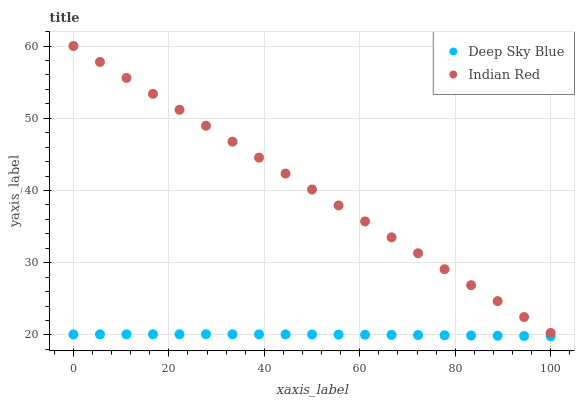Does Deep Sky Blue have the minimum area under the curve?
Answer yes or no. Yes. Does Indian Red have the maximum area under the curve?
Answer yes or no. Yes. Does Deep Sky Blue have the maximum area under the curve?
Answer yes or no. No. Is Indian Red the smoothest?
Answer yes or no. Yes. Is Deep Sky Blue the roughest?
Answer yes or no. Yes. Is Deep Sky Blue the smoothest?
Answer yes or no. No. Does Deep Sky Blue have the lowest value?
Answer yes or no. Yes. Does Indian Red have the highest value?
Answer yes or no. Yes. Does Deep Sky Blue have the highest value?
Answer yes or no. No. Is Deep Sky Blue less than Indian Red?
Answer yes or no. Yes. Is Indian Red greater than Deep Sky Blue?
Answer yes or no. Yes. Does Deep Sky Blue intersect Indian Red?
Answer yes or no. No. 